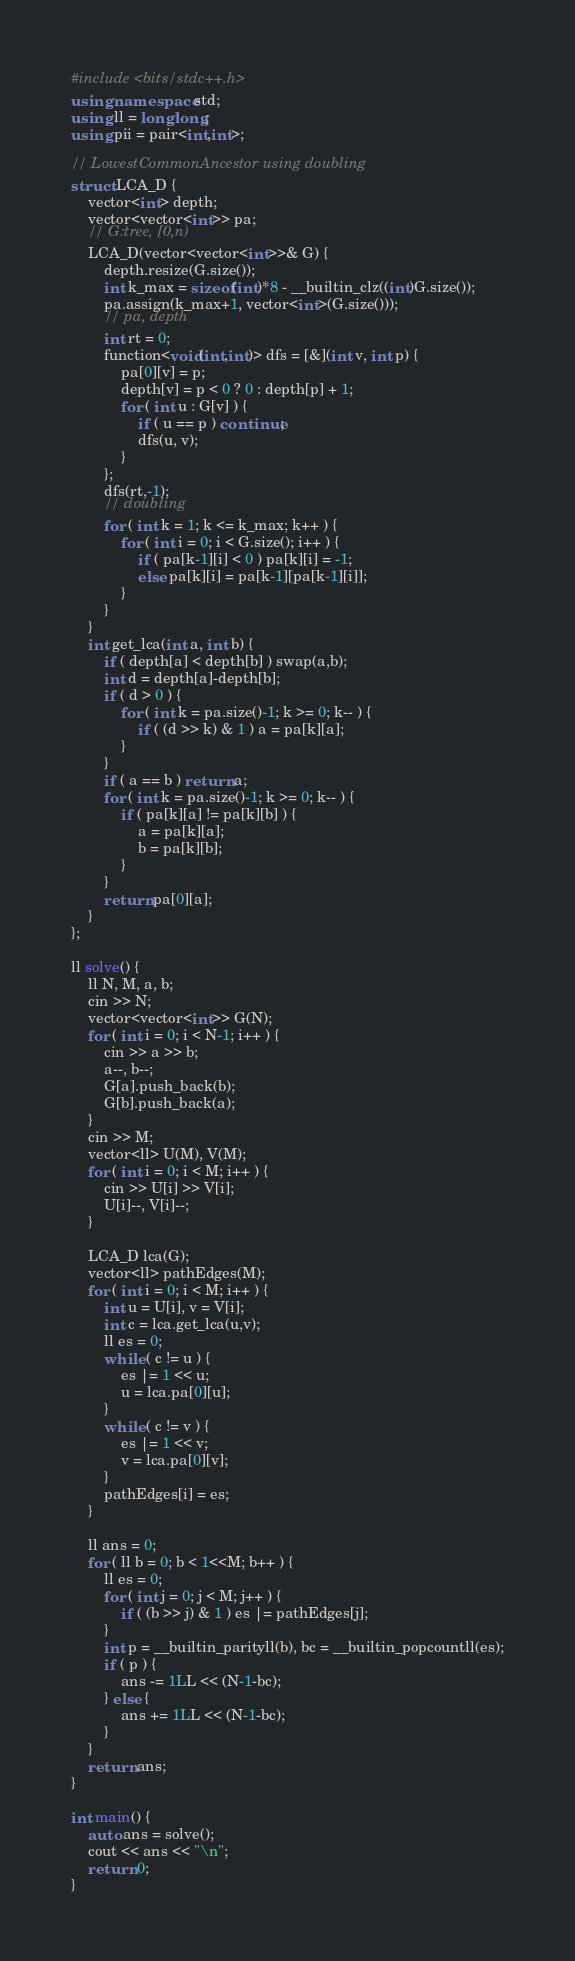Convert code to text. <code><loc_0><loc_0><loc_500><loc_500><_C++_>#include <bits/stdc++.h>
using namespace std;
using ll = long long;
using pii = pair<int,int>;

// LowestCommonAncestor using doubling
struct LCA_D {
    vector<int> depth;
    vector<vector<int>> pa;
    // G:tree, [0,n)
    LCA_D(vector<vector<int>>& G) {
        depth.resize(G.size());
        int k_max = sizeof(int)*8 - __builtin_clz((int)G.size());
        pa.assign(k_max+1, vector<int>(G.size()));
        // pa, depth
        int rt = 0;
        function<void(int,int)> dfs = [&](int v, int p) {
            pa[0][v] = p;
            depth[v] = p < 0 ? 0 : depth[p] + 1;
            for ( int u : G[v] ) {
                if ( u == p ) continue;
                dfs(u, v);
            }
        };
        dfs(rt,-1);
        // doubling
        for ( int k = 1; k <= k_max; k++ ) {
            for ( int i = 0; i < G.size(); i++ ) {
                if ( pa[k-1][i] < 0 ) pa[k][i] = -1;
                else pa[k][i] = pa[k-1][pa[k-1][i]];
            }
        }
    }
    int get_lca(int a, int b) {
        if ( depth[a] < depth[b] ) swap(a,b);
        int d = depth[a]-depth[b];
        if ( d > 0 ) {
            for ( int k = pa.size()-1; k >= 0; k-- ) {
                if ( (d >> k) & 1 ) a = pa[k][a];
            }
        }
        if ( a == b ) return a;
        for ( int k = pa.size()-1; k >= 0; k-- ) {
            if ( pa[k][a] != pa[k][b] ) {
                a = pa[k][a];
                b = pa[k][b];
            }
        }
        return pa[0][a];
    }
};

ll solve() {
    ll N, M, a, b;
    cin >> N;
    vector<vector<int>> G(N);
    for ( int i = 0; i < N-1; i++ ) {
        cin >> a >> b;
        a--, b--;
        G[a].push_back(b);
        G[b].push_back(a);
    }
    cin >> M;
    vector<ll> U(M), V(M);
    for ( int i = 0; i < M; i++ ) {
        cin >> U[i] >> V[i];
        U[i]--, V[i]--;
    }
    
    LCA_D lca(G);
    vector<ll> pathEdges(M);
    for ( int i = 0; i < M; i++ ) {
        int u = U[i], v = V[i];
        int c = lca.get_lca(u,v);
        ll es = 0;
        while ( c != u ) {
            es |= 1 << u;
            u = lca.pa[0][u];
        }
        while ( c != v ) {
            es |= 1 << v;
            v = lca.pa[0][v];
        }
        pathEdges[i] = es;
    }

    ll ans = 0;
    for ( ll b = 0; b < 1<<M; b++ ) {
        ll es = 0;
        for ( int j = 0; j < M; j++ ) {
            if ( (b >> j) & 1 ) es |= pathEdges[j];
        }
        int p = __builtin_parityll(b), bc = __builtin_popcountll(es);
        if ( p ) {
            ans -= 1LL << (N-1-bc);
        } else {
            ans += 1LL << (N-1-bc);
        }
    }
    return ans;
}

int main() {
    auto ans = solve();
    cout << ans << "\n";
    return 0;
}</code> 